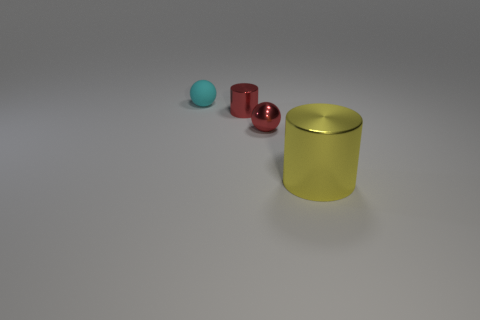Add 3 red shiny things. How many objects exist? 7 Add 3 cyan matte objects. How many cyan matte objects are left? 4 Add 3 red things. How many red things exist? 5 Subtract 0 gray cylinders. How many objects are left? 4 Subtract all tiny cyan objects. Subtract all red shiny cylinders. How many objects are left? 2 